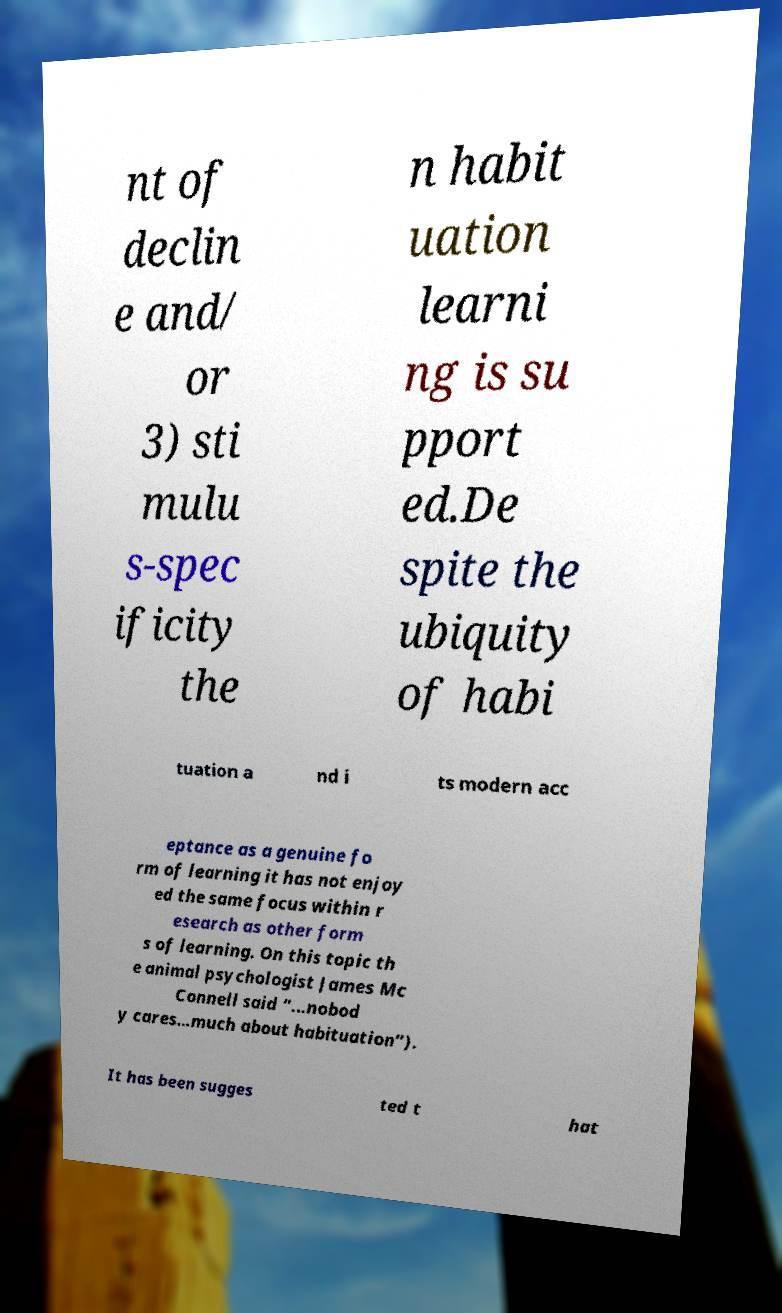Please read and relay the text visible in this image. What does it say? nt of declin e and/ or 3) sti mulu s-spec ificity the n habit uation learni ng is su pport ed.De spite the ubiquity of habi tuation a nd i ts modern acc eptance as a genuine fo rm of learning it has not enjoy ed the same focus within r esearch as other form s of learning. On this topic th e animal psychologist James Mc Connell said “...nobod y cares…much about habituation”). It has been sugges ted t hat 